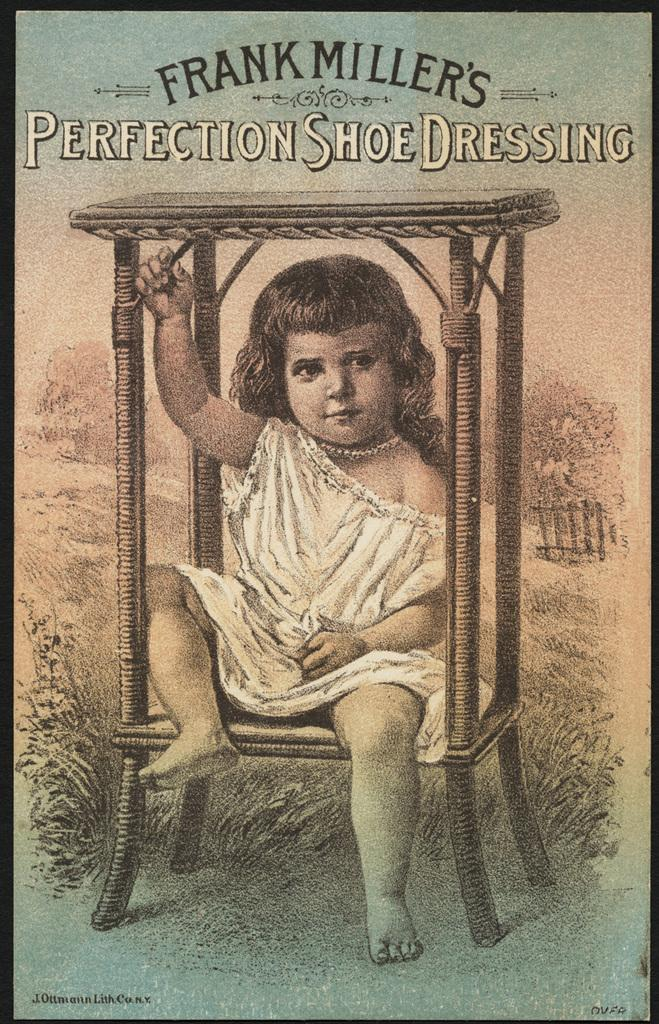<image>
Render a clear and concise summary of the photo. Cover of Frank millers Perfection Shoe Dressing with an illustration of a child. 